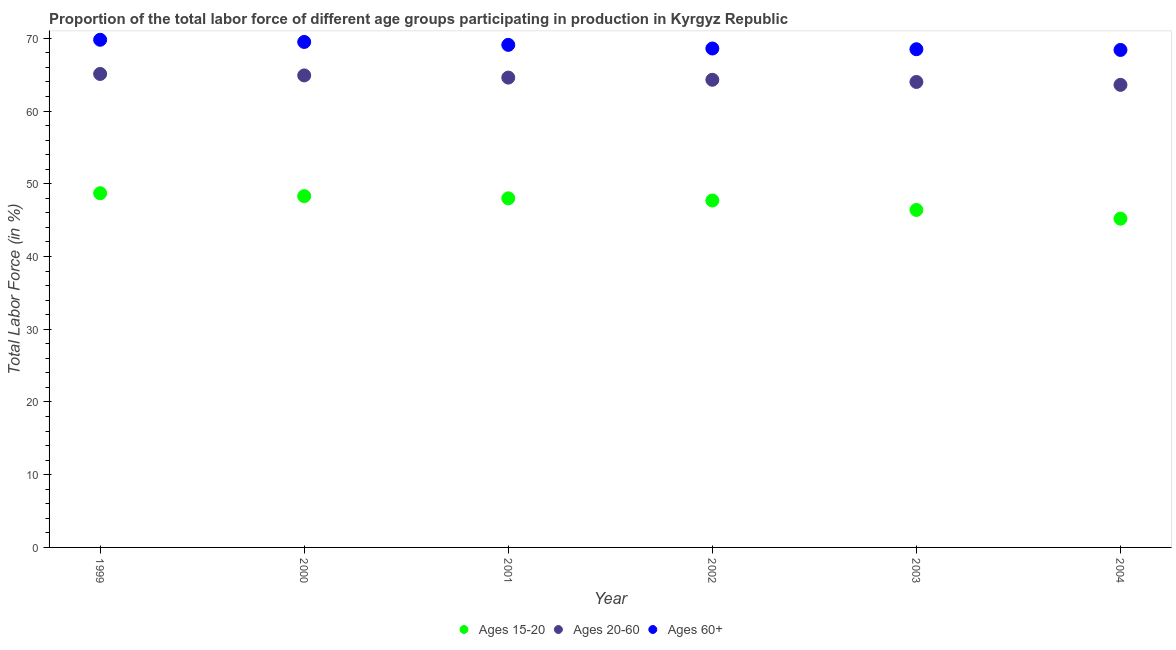How many different coloured dotlines are there?
Provide a succinct answer. 3. Is the number of dotlines equal to the number of legend labels?
Offer a terse response. Yes. What is the percentage of labor force above age 60 in 2004?
Your response must be concise. 68.4. Across all years, what is the maximum percentage of labor force within the age group 20-60?
Your answer should be compact. 65.1. Across all years, what is the minimum percentage of labor force within the age group 20-60?
Provide a short and direct response. 63.6. In which year was the percentage of labor force within the age group 20-60 minimum?
Give a very brief answer. 2004. What is the total percentage of labor force within the age group 20-60 in the graph?
Offer a very short reply. 386.5. What is the difference between the percentage of labor force within the age group 20-60 in 1999 and that in 2002?
Offer a terse response. 0.8. What is the difference between the percentage of labor force within the age group 15-20 in 2001 and the percentage of labor force within the age group 20-60 in 2004?
Provide a short and direct response. -15.6. What is the average percentage of labor force above age 60 per year?
Your response must be concise. 68.98. In the year 1999, what is the difference between the percentage of labor force within the age group 20-60 and percentage of labor force within the age group 15-20?
Your answer should be compact. 16.4. In how many years, is the percentage of labor force within the age group 20-60 greater than 50 %?
Keep it short and to the point. 6. What is the ratio of the percentage of labor force above age 60 in 1999 to that in 2001?
Make the answer very short. 1.01. Is the percentage of labor force within the age group 20-60 in 1999 less than that in 2003?
Provide a short and direct response. No. What is the difference between the highest and the second highest percentage of labor force within the age group 15-20?
Give a very brief answer. 0.4. In how many years, is the percentage of labor force within the age group 20-60 greater than the average percentage of labor force within the age group 20-60 taken over all years?
Your response must be concise. 3. Is the sum of the percentage of labor force within the age group 15-20 in 1999 and 2002 greater than the maximum percentage of labor force above age 60 across all years?
Provide a short and direct response. Yes. Does the percentage of labor force within the age group 20-60 monotonically increase over the years?
Keep it short and to the point. No. Is the percentage of labor force within the age group 20-60 strictly less than the percentage of labor force within the age group 15-20 over the years?
Offer a terse response. No. How many dotlines are there?
Offer a very short reply. 3. What is the difference between two consecutive major ticks on the Y-axis?
Ensure brevity in your answer.  10. Does the graph contain any zero values?
Provide a short and direct response. No. Where does the legend appear in the graph?
Offer a very short reply. Bottom center. How many legend labels are there?
Keep it short and to the point. 3. How are the legend labels stacked?
Your response must be concise. Horizontal. What is the title of the graph?
Your answer should be very brief. Proportion of the total labor force of different age groups participating in production in Kyrgyz Republic. What is the Total Labor Force (in %) of Ages 15-20 in 1999?
Give a very brief answer. 48.7. What is the Total Labor Force (in %) in Ages 20-60 in 1999?
Ensure brevity in your answer.  65.1. What is the Total Labor Force (in %) of Ages 60+ in 1999?
Make the answer very short. 69.8. What is the Total Labor Force (in %) of Ages 15-20 in 2000?
Offer a very short reply. 48.3. What is the Total Labor Force (in %) of Ages 20-60 in 2000?
Your answer should be very brief. 64.9. What is the Total Labor Force (in %) in Ages 60+ in 2000?
Your answer should be very brief. 69.5. What is the Total Labor Force (in %) in Ages 20-60 in 2001?
Offer a very short reply. 64.6. What is the Total Labor Force (in %) of Ages 60+ in 2001?
Offer a very short reply. 69.1. What is the Total Labor Force (in %) of Ages 15-20 in 2002?
Offer a terse response. 47.7. What is the Total Labor Force (in %) in Ages 20-60 in 2002?
Your answer should be very brief. 64.3. What is the Total Labor Force (in %) of Ages 60+ in 2002?
Give a very brief answer. 68.6. What is the Total Labor Force (in %) in Ages 15-20 in 2003?
Your answer should be very brief. 46.4. What is the Total Labor Force (in %) in Ages 20-60 in 2003?
Ensure brevity in your answer.  64. What is the Total Labor Force (in %) of Ages 60+ in 2003?
Provide a succinct answer. 68.5. What is the Total Labor Force (in %) in Ages 15-20 in 2004?
Give a very brief answer. 45.2. What is the Total Labor Force (in %) in Ages 20-60 in 2004?
Make the answer very short. 63.6. What is the Total Labor Force (in %) of Ages 60+ in 2004?
Your answer should be compact. 68.4. Across all years, what is the maximum Total Labor Force (in %) of Ages 15-20?
Provide a short and direct response. 48.7. Across all years, what is the maximum Total Labor Force (in %) in Ages 20-60?
Ensure brevity in your answer.  65.1. Across all years, what is the maximum Total Labor Force (in %) of Ages 60+?
Your answer should be very brief. 69.8. Across all years, what is the minimum Total Labor Force (in %) in Ages 15-20?
Your response must be concise. 45.2. Across all years, what is the minimum Total Labor Force (in %) in Ages 20-60?
Keep it short and to the point. 63.6. Across all years, what is the minimum Total Labor Force (in %) in Ages 60+?
Keep it short and to the point. 68.4. What is the total Total Labor Force (in %) of Ages 15-20 in the graph?
Provide a succinct answer. 284.3. What is the total Total Labor Force (in %) in Ages 20-60 in the graph?
Ensure brevity in your answer.  386.5. What is the total Total Labor Force (in %) in Ages 60+ in the graph?
Give a very brief answer. 413.9. What is the difference between the Total Labor Force (in %) of Ages 60+ in 1999 and that in 2000?
Your answer should be compact. 0.3. What is the difference between the Total Labor Force (in %) of Ages 15-20 in 1999 and that in 2001?
Ensure brevity in your answer.  0.7. What is the difference between the Total Labor Force (in %) in Ages 60+ in 1999 and that in 2001?
Ensure brevity in your answer.  0.7. What is the difference between the Total Labor Force (in %) of Ages 15-20 in 1999 and that in 2002?
Give a very brief answer. 1. What is the difference between the Total Labor Force (in %) in Ages 60+ in 1999 and that in 2002?
Your response must be concise. 1.2. What is the difference between the Total Labor Force (in %) of Ages 60+ in 1999 and that in 2003?
Ensure brevity in your answer.  1.3. What is the difference between the Total Labor Force (in %) in Ages 15-20 in 2000 and that in 2001?
Make the answer very short. 0.3. What is the difference between the Total Labor Force (in %) of Ages 15-20 in 2000 and that in 2002?
Keep it short and to the point. 0.6. What is the difference between the Total Labor Force (in %) in Ages 20-60 in 2000 and that in 2002?
Your response must be concise. 0.6. What is the difference between the Total Labor Force (in %) in Ages 60+ in 2000 and that in 2002?
Your response must be concise. 0.9. What is the difference between the Total Labor Force (in %) of Ages 20-60 in 2000 and that in 2003?
Give a very brief answer. 0.9. What is the difference between the Total Labor Force (in %) of Ages 60+ in 2000 and that in 2003?
Your answer should be compact. 1. What is the difference between the Total Labor Force (in %) of Ages 15-20 in 2000 and that in 2004?
Provide a short and direct response. 3.1. What is the difference between the Total Labor Force (in %) in Ages 60+ in 2000 and that in 2004?
Make the answer very short. 1.1. What is the difference between the Total Labor Force (in %) in Ages 15-20 in 2001 and that in 2002?
Offer a terse response. 0.3. What is the difference between the Total Labor Force (in %) of Ages 20-60 in 2001 and that in 2002?
Make the answer very short. 0.3. What is the difference between the Total Labor Force (in %) in Ages 60+ in 2001 and that in 2002?
Make the answer very short. 0.5. What is the difference between the Total Labor Force (in %) in Ages 60+ in 2001 and that in 2003?
Your answer should be compact. 0.6. What is the difference between the Total Labor Force (in %) of Ages 20-60 in 2001 and that in 2004?
Offer a very short reply. 1. What is the difference between the Total Labor Force (in %) of Ages 60+ in 2001 and that in 2004?
Offer a terse response. 0.7. What is the difference between the Total Labor Force (in %) in Ages 60+ in 2002 and that in 2004?
Your answer should be compact. 0.2. What is the difference between the Total Labor Force (in %) in Ages 15-20 in 2003 and that in 2004?
Your answer should be compact. 1.2. What is the difference between the Total Labor Force (in %) in Ages 15-20 in 1999 and the Total Labor Force (in %) in Ages 20-60 in 2000?
Provide a succinct answer. -16.2. What is the difference between the Total Labor Force (in %) of Ages 15-20 in 1999 and the Total Labor Force (in %) of Ages 60+ in 2000?
Offer a terse response. -20.8. What is the difference between the Total Labor Force (in %) in Ages 20-60 in 1999 and the Total Labor Force (in %) in Ages 60+ in 2000?
Your response must be concise. -4.4. What is the difference between the Total Labor Force (in %) of Ages 15-20 in 1999 and the Total Labor Force (in %) of Ages 20-60 in 2001?
Ensure brevity in your answer.  -15.9. What is the difference between the Total Labor Force (in %) of Ages 15-20 in 1999 and the Total Labor Force (in %) of Ages 60+ in 2001?
Ensure brevity in your answer.  -20.4. What is the difference between the Total Labor Force (in %) of Ages 20-60 in 1999 and the Total Labor Force (in %) of Ages 60+ in 2001?
Your answer should be very brief. -4. What is the difference between the Total Labor Force (in %) of Ages 15-20 in 1999 and the Total Labor Force (in %) of Ages 20-60 in 2002?
Your answer should be very brief. -15.6. What is the difference between the Total Labor Force (in %) of Ages 15-20 in 1999 and the Total Labor Force (in %) of Ages 60+ in 2002?
Give a very brief answer. -19.9. What is the difference between the Total Labor Force (in %) of Ages 15-20 in 1999 and the Total Labor Force (in %) of Ages 20-60 in 2003?
Keep it short and to the point. -15.3. What is the difference between the Total Labor Force (in %) in Ages 15-20 in 1999 and the Total Labor Force (in %) in Ages 60+ in 2003?
Give a very brief answer. -19.8. What is the difference between the Total Labor Force (in %) in Ages 20-60 in 1999 and the Total Labor Force (in %) in Ages 60+ in 2003?
Offer a terse response. -3.4. What is the difference between the Total Labor Force (in %) of Ages 15-20 in 1999 and the Total Labor Force (in %) of Ages 20-60 in 2004?
Keep it short and to the point. -14.9. What is the difference between the Total Labor Force (in %) in Ages 15-20 in 1999 and the Total Labor Force (in %) in Ages 60+ in 2004?
Make the answer very short. -19.7. What is the difference between the Total Labor Force (in %) of Ages 15-20 in 2000 and the Total Labor Force (in %) of Ages 20-60 in 2001?
Your answer should be compact. -16.3. What is the difference between the Total Labor Force (in %) of Ages 15-20 in 2000 and the Total Labor Force (in %) of Ages 60+ in 2001?
Ensure brevity in your answer.  -20.8. What is the difference between the Total Labor Force (in %) of Ages 15-20 in 2000 and the Total Labor Force (in %) of Ages 60+ in 2002?
Offer a terse response. -20.3. What is the difference between the Total Labor Force (in %) in Ages 20-60 in 2000 and the Total Labor Force (in %) in Ages 60+ in 2002?
Give a very brief answer. -3.7. What is the difference between the Total Labor Force (in %) of Ages 15-20 in 2000 and the Total Labor Force (in %) of Ages 20-60 in 2003?
Give a very brief answer. -15.7. What is the difference between the Total Labor Force (in %) of Ages 15-20 in 2000 and the Total Labor Force (in %) of Ages 60+ in 2003?
Offer a terse response. -20.2. What is the difference between the Total Labor Force (in %) in Ages 20-60 in 2000 and the Total Labor Force (in %) in Ages 60+ in 2003?
Your answer should be compact. -3.6. What is the difference between the Total Labor Force (in %) in Ages 15-20 in 2000 and the Total Labor Force (in %) in Ages 20-60 in 2004?
Your response must be concise. -15.3. What is the difference between the Total Labor Force (in %) of Ages 15-20 in 2000 and the Total Labor Force (in %) of Ages 60+ in 2004?
Offer a terse response. -20.1. What is the difference between the Total Labor Force (in %) in Ages 15-20 in 2001 and the Total Labor Force (in %) in Ages 20-60 in 2002?
Provide a succinct answer. -16.3. What is the difference between the Total Labor Force (in %) of Ages 15-20 in 2001 and the Total Labor Force (in %) of Ages 60+ in 2002?
Give a very brief answer. -20.6. What is the difference between the Total Labor Force (in %) in Ages 15-20 in 2001 and the Total Labor Force (in %) in Ages 60+ in 2003?
Give a very brief answer. -20.5. What is the difference between the Total Labor Force (in %) in Ages 15-20 in 2001 and the Total Labor Force (in %) in Ages 20-60 in 2004?
Your answer should be compact. -15.6. What is the difference between the Total Labor Force (in %) of Ages 15-20 in 2001 and the Total Labor Force (in %) of Ages 60+ in 2004?
Your answer should be compact. -20.4. What is the difference between the Total Labor Force (in %) of Ages 15-20 in 2002 and the Total Labor Force (in %) of Ages 20-60 in 2003?
Offer a terse response. -16.3. What is the difference between the Total Labor Force (in %) in Ages 15-20 in 2002 and the Total Labor Force (in %) in Ages 60+ in 2003?
Your response must be concise. -20.8. What is the difference between the Total Labor Force (in %) in Ages 20-60 in 2002 and the Total Labor Force (in %) in Ages 60+ in 2003?
Offer a very short reply. -4.2. What is the difference between the Total Labor Force (in %) of Ages 15-20 in 2002 and the Total Labor Force (in %) of Ages 20-60 in 2004?
Provide a short and direct response. -15.9. What is the difference between the Total Labor Force (in %) of Ages 15-20 in 2002 and the Total Labor Force (in %) of Ages 60+ in 2004?
Your response must be concise. -20.7. What is the difference between the Total Labor Force (in %) of Ages 20-60 in 2002 and the Total Labor Force (in %) of Ages 60+ in 2004?
Your answer should be compact. -4.1. What is the difference between the Total Labor Force (in %) in Ages 15-20 in 2003 and the Total Labor Force (in %) in Ages 20-60 in 2004?
Keep it short and to the point. -17.2. What is the average Total Labor Force (in %) in Ages 15-20 per year?
Offer a terse response. 47.38. What is the average Total Labor Force (in %) of Ages 20-60 per year?
Your response must be concise. 64.42. What is the average Total Labor Force (in %) of Ages 60+ per year?
Make the answer very short. 68.98. In the year 1999, what is the difference between the Total Labor Force (in %) in Ages 15-20 and Total Labor Force (in %) in Ages 20-60?
Your answer should be compact. -16.4. In the year 1999, what is the difference between the Total Labor Force (in %) of Ages 15-20 and Total Labor Force (in %) of Ages 60+?
Offer a very short reply. -21.1. In the year 1999, what is the difference between the Total Labor Force (in %) in Ages 20-60 and Total Labor Force (in %) in Ages 60+?
Keep it short and to the point. -4.7. In the year 2000, what is the difference between the Total Labor Force (in %) in Ages 15-20 and Total Labor Force (in %) in Ages 20-60?
Ensure brevity in your answer.  -16.6. In the year 2000, what is the difference between the Total Labor Force (in %) of Ages 15-20 and Total Labor Force (in %) of Ages 60+?
Offer a terse response. -21.2. In the year 2001, what is the difference between the Total Labor Force (in %) of Ages 15-20 and Total Labor Force (in %) of Ages 20-60?
Keep it short and to the point. -16.6. In the year 2001, what is the difference between the Total Labor Force (in %) of Ages 15-20 and Total Labor Force (in %) of Ages 60+?
Your answer should be very brief. -21.1. In the year 2002, what is the difference between the Total Labor Force (in %) of Ages 15-20 and Total Labor Force (in %) of Ages 20-60?
Ensure brevity in your answer.  -16.6. In the year 2002, what is the difference between the Total Labor Force (in %) in Ages 15-20 and Total Labor Force (in %) in Ages 60+?
Offer a very short reply. -20.9. In the year 2002, what is the difference between the Total Labor Force (in %) of Ages 20-60 and Total Labor Force (in %) of Ages 60+?
Ensure brevity in your answer.  -4.3. In the year 2003, what is the difference between the Total Labor Force (in %) of Ages 15-20 and Total Labor Force (in %) of Ages 20-60?
Make the answer very short. -17.6. In the year 2003, what is the difference between the Total Labor Force (in %) in Ages 15-20 and Total Labor Force (in %) in Ages 60+?
Offer a very short reply. -22.1. In the year 2003, what is the difference between the Total Labor Force (in %) of Ages 20-60 and Total Labor Force (in %) of Ages 60+?
Your answer should be compact. -4.5. In the year 2004, what is the difference between the Total Labor Force (in %) in Ages 15-20 and Total Labor Force (in %) in Ages 20-60?
Give a very brief answer. -18.4. In the year 2004, what is the difference between the Total Labor Force (in %) in Ages 15-20 and Total Labor Force (in %) in Ages 60+?
Give a very brief answer. -23.2. What is the ratio of the Total Labor Force (in %) of Ages 15-20 in 1999 to that in 2000?
Make the answer very short. 1.01. What is the ratio of the Total Labor Force (in %) in Ages 60+ in 1999 to that in 2000?
Provide a succinct answer. 1. What is the ratio of the Total Labor Force (in %) of Ages 15-20 in 1999 to that in 2001?
Give a very brief answer. 1.01. What is the ratio of the Total Labor Force (in %) of Ages 20-60 in 1999 to that in 2001?
Offer a terse response. 1.01. What is the ratio of the Total Labor Force (in %) of Ages 60+ in 1999 to that in 2001?
Provide a succinct answer. 1.01. What is the ratio of the Total Labor Force (in %) in Ages 20-60 in 1999 to that in 2002?
Offer a terse response. 1.01. What is the ratio of the Total Labor Force (in %) of Ages 60+ in 1999 to that in 2002?
Ensure brevity in your answer.  1.02. What is the ratio of the Total Labor Force (in %) in Ages 15-20 in 1999 to that in 2003?
Provide a short and direct response. 1.05. What is the ratio of the Total Labor Force (in %) in Ages 20-60 in 1999 to that in 2003?
Your answer should be compact. 1.02. What is the ratio of the Total Labor Force (in %) in Ages 60+ in 1999 to that in 2003?
Keep it short and to the point. 1.02. What is the ratio of the Total Labor Force (in %) of Ages 15-20 in 1999 to that in 2004?
Ensure brevity in your answer.  1.08. What is the ratio of the Total Labor Force (in %) in Ages 20-60 in 1999 to that in 2004?
Your answer should be very brief. 1.02. What is the ratio of the Total Labor Force (in %) in Ages 60+ in 1999 to that in 2004?
Your answer should be very brief. 1.02. What is the ratio of the Total Labor Force (in %) of Ages 15-20 in 2000 to that in 2001?
Ensure brevity in your answer.  1.01. What is the ratio of the Total Labor Force (in %) of Ages 15-20 in 2000 to that in 2002?
Provide a succinct answer. 1.01. What is the ratio of the Total Labor Force (in %) in Ages 20-60 in 2000 to that in 2002?
Provide a short and direct response. 1.01. What is the ratio of the Total Labor Force (in %) in Ages 60+ in 2000 to that in 2002?
Provide a short and direct response. 1.01. What is the ratio of the Total Labor Force (in %) in Ages 15-20 in 2000 to that in 2003?
Keep it short and to the point. 1.04. What is the ratio of the Total Labor Force (in %) of Ages 20-60 in 2000 to that in 2003?
Provide a succinct answer. 1.01. What is the ratio of the Total Labor Force (in %) in Ages 60+ in 2000 to that in 2003?
Ensure brevity in your answer.  1.01. What is the ratio of the Total Labor Force (in %) of Ages 15-20 in 2000 to that in 2004?
Make the answer very short. 1.07. What is the ratio of the Total Labor Force (in %) in Ages 20-60 in 2000 to that in 2004?
Offer a terse response. 1.02. What is the ratio of the Total Labor Force (in %) in Ages 60+ in 2000 to that in 2004?
Provide a succinct answer. 1.02. What is the ratio of the Total Labor Force (in %) of Ages 15-20 in 2001 to that in 2002?
Your answer should be compact. 1.01. What is the ratio of the Total Labor Force (in %) in Ages 20-60 in 2001 to that in 2002?
Offer a very short reply. 1. What is the ratio of the Total Labor Force (in %) in Ages 60+ in 2001 to that in 2002?
Ensure brevity in your answer.  1.01. What is the ratio of the Total Labor Force (in %) in Ages 15-20 in 2001 to that in 2003?
Keep it short and to the point. 1.03. What is the ratio of the Total Labor Force (in %) of Ages 20-60 in 2001 to that in 2003?
Ensure brevity in your answer.  1.01. What is the ratio of the Total Labor Force (in %) of Ages 60+ in 2001 to that in 2003?
Make the answer very short. 1.01. What is the ratio of the Total Labor Force (in %) in Ages 15-20 in 2001 to that in 2004?
Your answer should be compact. 1.06. What is the ratio of the Total Labor Force (in %) of Ages 20-60 in 2001 to that in 2004?
Your response must be concise. 1.02. What is the ratio of the Total Labor Force (in %) of Ages 60+ in 2001 to that in 2004?
Offer a very short reply. 1.01. What is the ratio of the Total Labor Force (in %) of Ages 15-20 in 2002 to that in 2003?
Ensure brevity in your answer.  1.03. What is the ratio of the Total Labor Force (in %) in Ages 20-60 in 2002 to that in 2003?
Your response must be concise. 1. What is the ratio of the Total Labor Force (in %) of Ages 15-20 in 2002 to that in 2004?
Your answer should be compact. 1.06. What is the ratio of the Total Labor Force (in %) of Ages 20-60 in 2002 to that in 2004?
Offer a very short reply. 1.01. What is the ratio of the Total Labor Force (in %) in Ages 15-20 in 2003 to that in 2004?
Offer a terse response. 1.03. What is the ratio of the Total Labor Force (in %) in Ages 20-60 in 2003 to that in 2004?
Keep it short and to the point. 1.01. What is the difference between the highest and the second highest Total Labor Force (in %) of Ages 20-60?
Ensure brevity in your answer.  0.2. What is the difference between the highest and the lowest Total Labor Force (in %) in Ages 60+?
Your answer should be very brief. 1.4. 